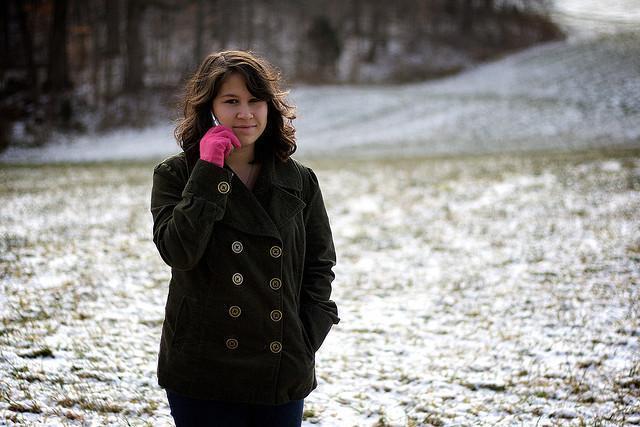How many buttons on the coat?
Give a very brief answer. 9. 